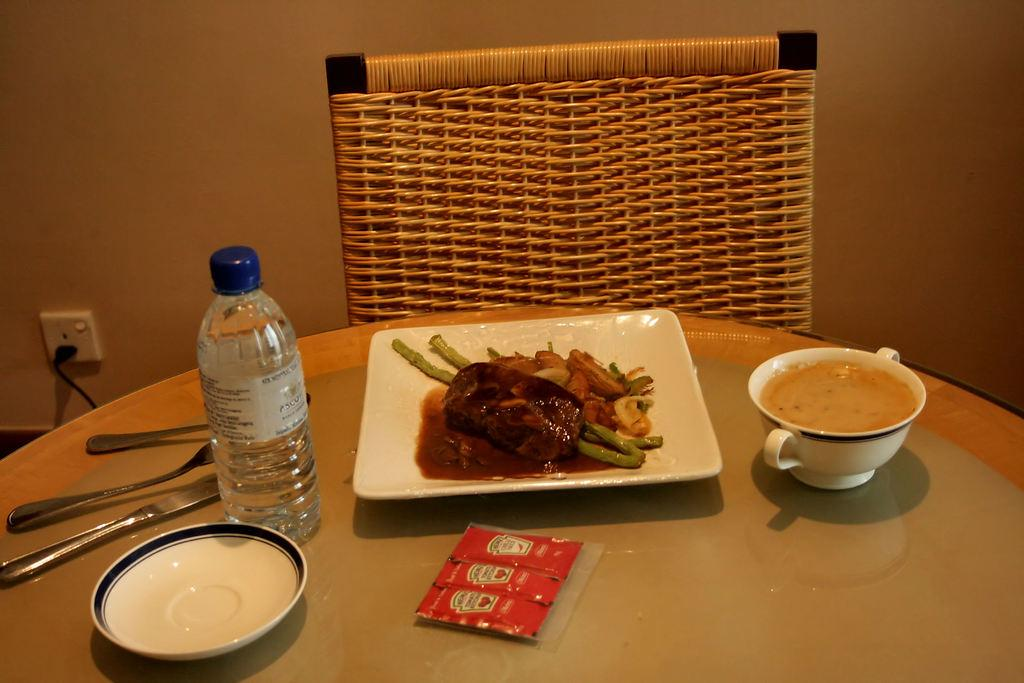What is on the plate that is visible in the image? There is a plate with food in the image. What beverage container is present in the image? There is a water bottle in the image. Where is the water bottle located in relation to the chair? The water bottle is in front of a chair. In which type of space are the objects located? The objects are located in a room. What type of steel is used to construct the boundary of the room in the image? There is no mention of a boundary or steel in the image; it only shows a plate with food, a water bottle, and a chair in a room. 